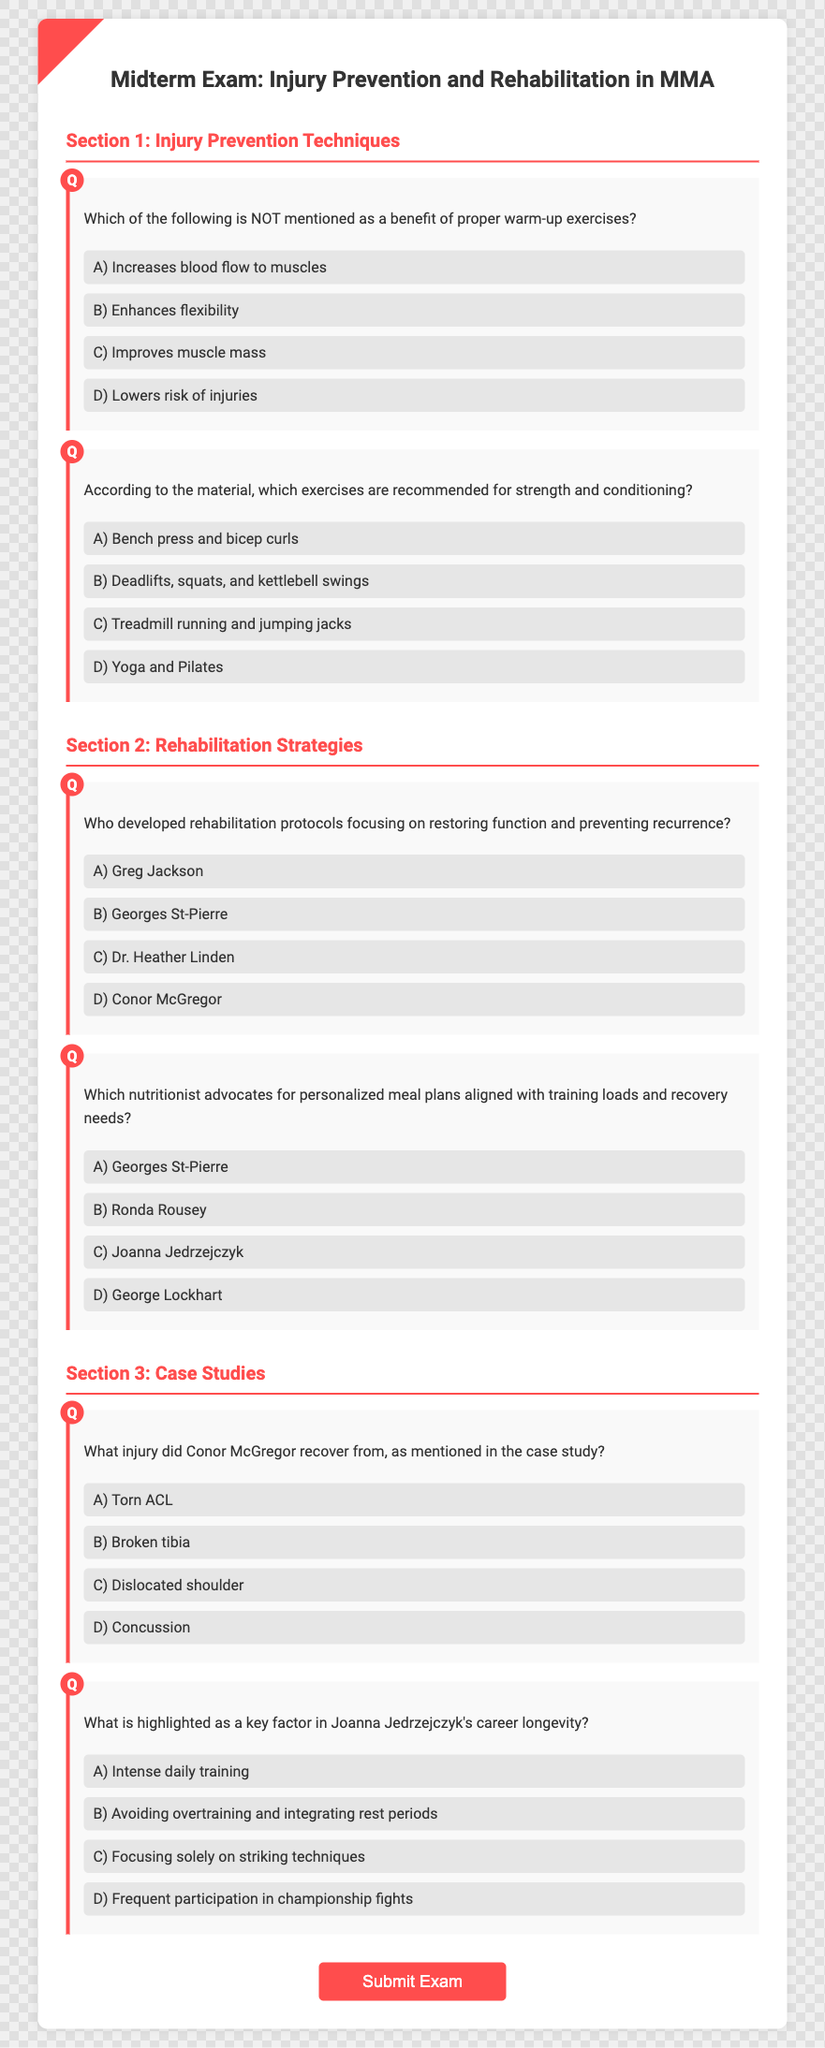What is the title of the exam? The title displayed prominently at the top of the document is the focus of the exam, which is "Midterm Exam: Injury Prevention and Rehabilitation in MMA."
Answer: Midterm Exam: Injury Prevention and Rehabilitation in MMA Which section discusses Injury Prevention Techniques? The sections are clearly labeled in the document, with the first section titled "Section 1: Injury Prevention Techniques."
Answer: Section 1: Injury Prevention Techniques Who is mentioned as the nutritionist for personalized meal plans? Within the document, one of the options in the question is "George Lockhart," who is recognized for advocating personalized meal plans.
Answer: George Lockhart What rehabilitative method does Dr. Heather Linden focus on? The question related to Dr. Heather Linden highlights her work on "restoring function and preventing recurrence," which reflects her approach to rehabilitation.
Answer: Restoring function and preventing recurrence What injury did Conor McGregor recover from? The document specifies the injury found in the case study, which is "Broken tibia," clarifying McGregor's experience with injury.
Answer: Broken tibia Which practice is emphasized for Joanna Jedrzejczyk's longevity? The document indicates that "avoiding overtraining and integrating rest periods" is emphasized as a key factor in her career longevity.
Answer: Avoiding overtraining and integrating rest periods 